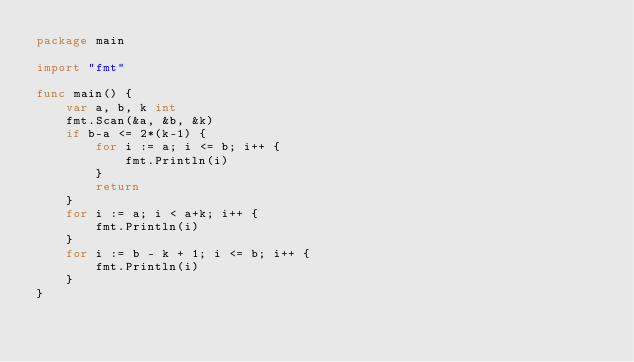Convert code to text. <code><loc_0><loc_0><loc_500><loc_500><_Go_>package main

import "fmt"

func main() {
	var a, b, k int
	fmt.Scan(&a, &b, &k)
	if b-a <= 2*(k-1) {
		for i := a; i <= b; i++ {
			fmt.Println(i)
		}
		return
	}
	for i := a; i < a+k; i++ {
		fmt.Println(i)
	}
	for i := b - k + 1; i <= b; i++ {
		fmt.Println(i)
	}
}
</code> 